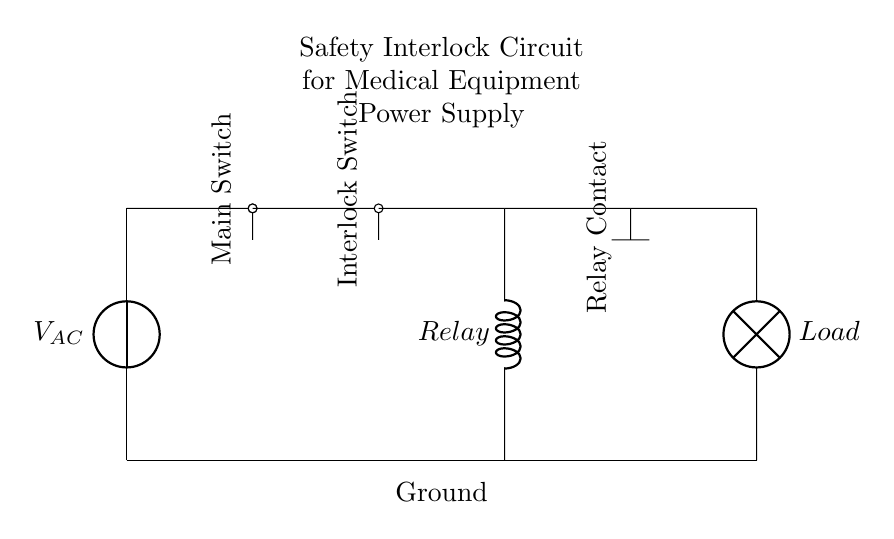What is the type of the power source? The circuit uses an alternating current power source, as indicated by the symbol for the voltage source labeled as V_AC.
Answer: Alternating current What is the function of the interlock switch? The interlock switch ensures that the circuit cannot be completed unless certain safety conditions are met, which typically involve confirming that the medical equipment is safe to operate.
Answer: Safety How many switches are present in the circuit? There are two switches: the main switch and the interlock switch, both of which are required for operation.
Answer: Two What happens when the relay is activated? When the relay is activated, it closes its contact, allowing current to flow to the load, which powers the connected medical equipment.
Answer: Powers the load Describe the load connected in the circuit. The load is represented by a lamp symbol, indicating that this circuit can be connected to a device or appliance, likely a medical device in this context.
Answer: Lamp How is the circuit grounded? The circuit is grounded by a connection to a reference point labeled "Ground," which is connected from the power supply to the bottom rung of the circuit.
Answer: Ground What is the labeled component for controlling the load? The controlling component in the circuit is labeled as "Relay," which indicates its function of switching the load on or off based on the circuit conditions.
Answer: Relay 